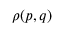<formula> <loc_0><loc_0><loc_500><loc_500>\rho ( p , q )</formula> 